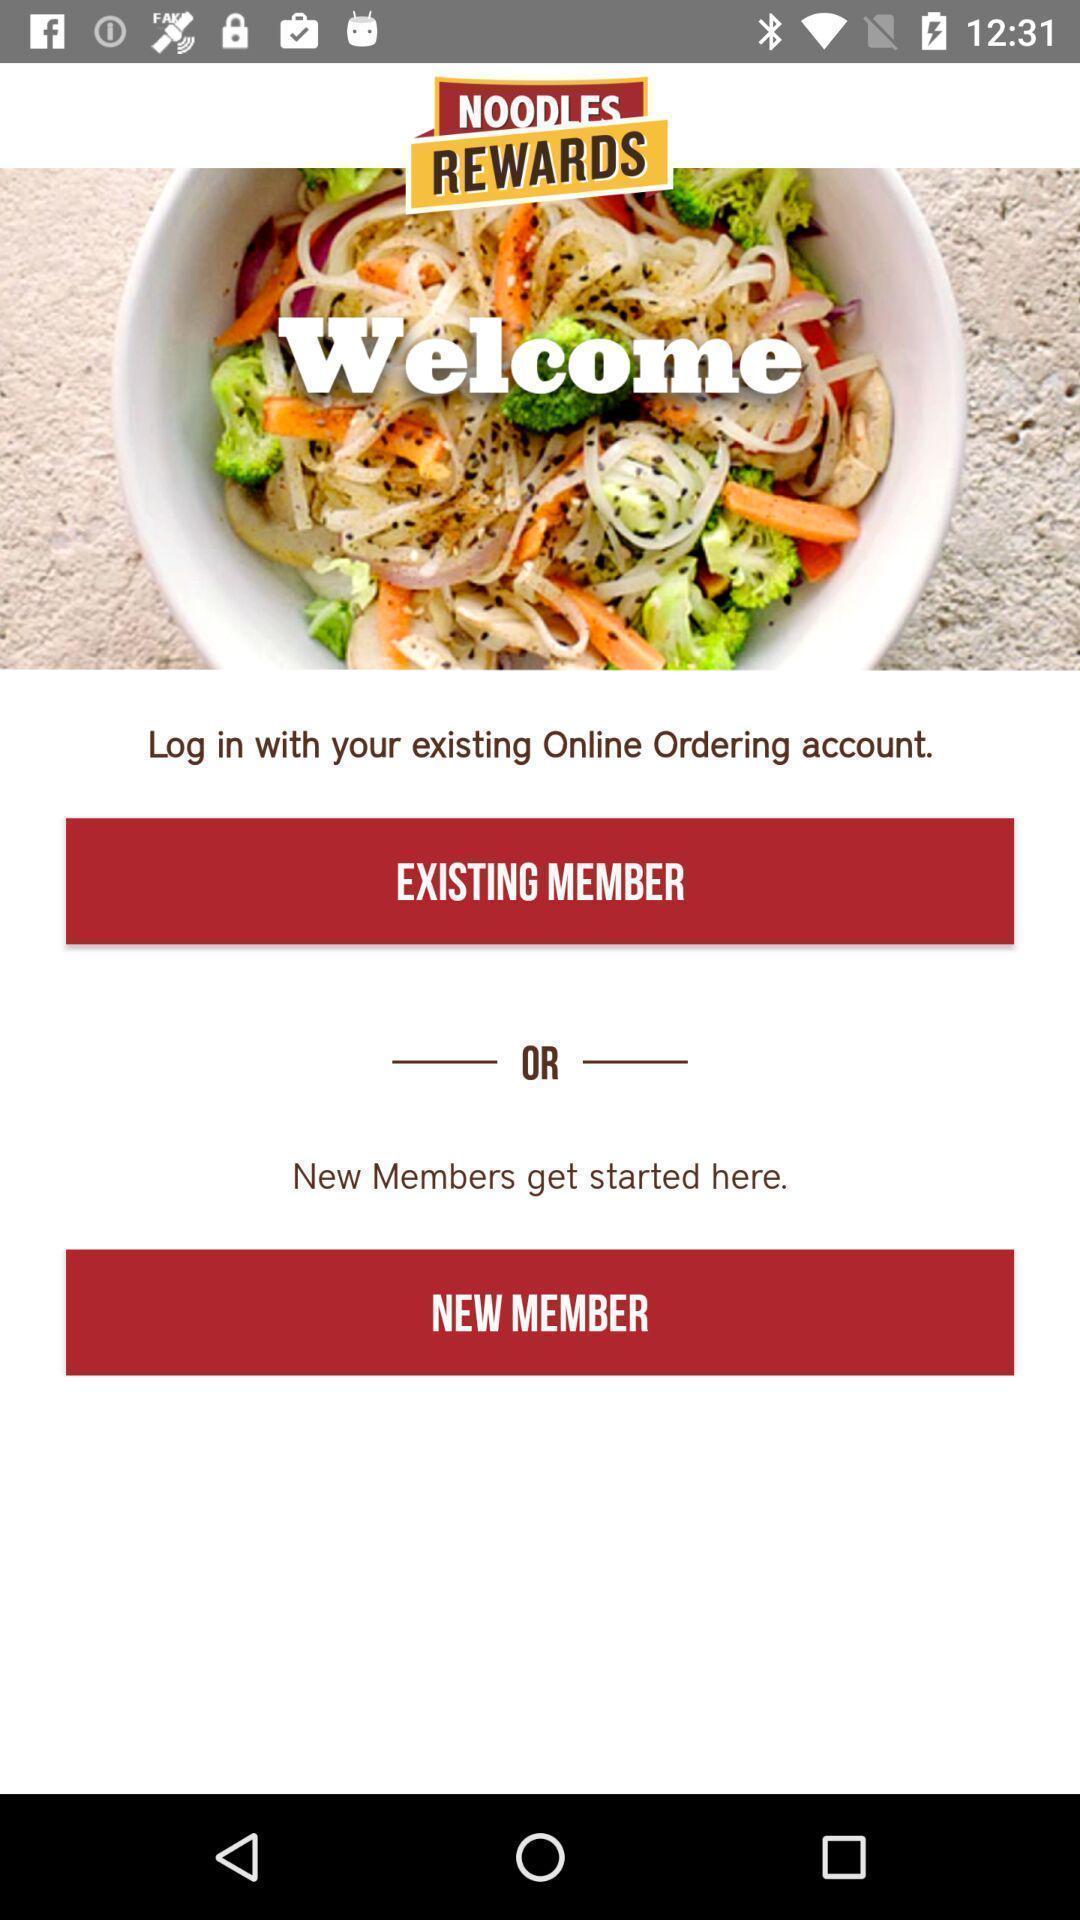Provide a description of this screenshot. Welcome page of food application. 